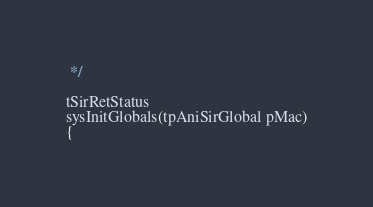<code> <loc_0><loc_0><loc_500><loc_500><_C_> */

tSirRetStatus
sysInitGlobals(tpAniSirGlobal pMac)
{
</code> 